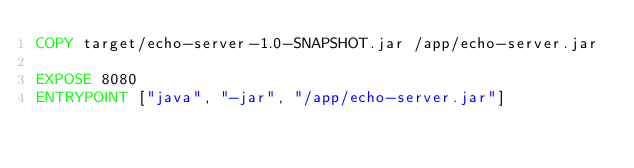<code> <loc_0><loc_0><loc_500><loc_500><_Dockerfile_>COPY target/echo-server-1.0-SNAPSHOT.jar /app/echo-server.jar

EXPOSE 8080
ENTRYPOINT ["java", "-jar", "/app/echo-server.jar"]
 

</code> 